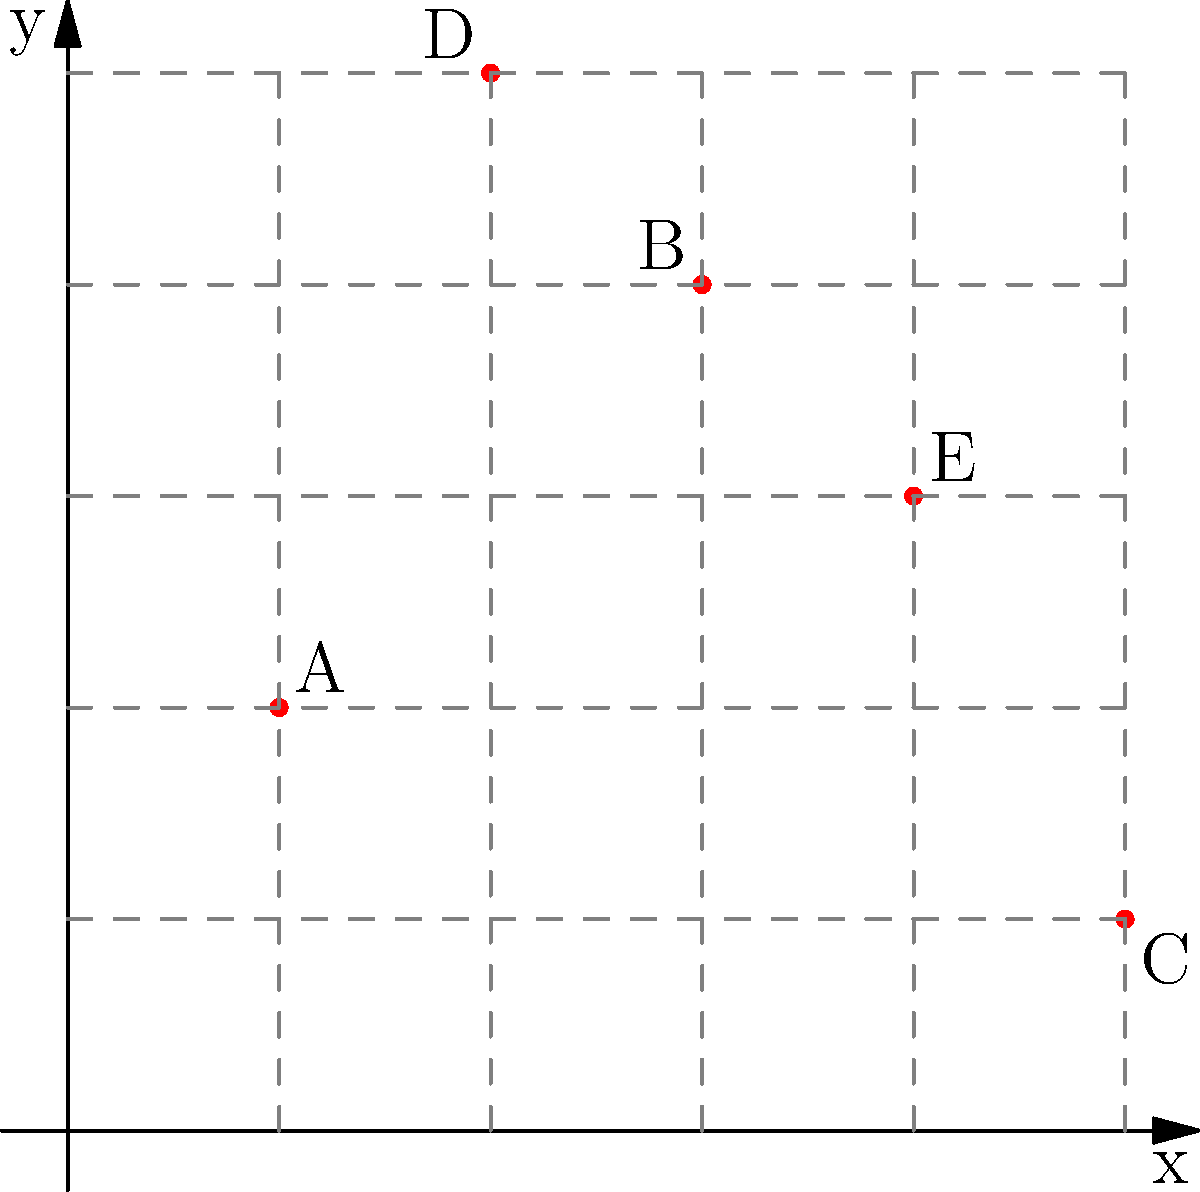As a city council member, you're presented with a map showing crime hotspots in your city. The map uses a coordinate system where each unit represents one city block. Five major hotspots (A, B, C, D, and E) have been identified. What is the Manhattan distance between the two hotspots that are farthest apart? (The Manhattan distance is the sum of the absolute differences of the coordinates.) To solve this problem, we need to:

1. Identify the coordinates of each hotspot:
   A: $(1,2)$
   B: $(3,4)$
   C: $(5,1)$
   D: $(2,5)$
   E: $(4,3)$

2. Calculate the Manhattan distance between each pair of points using the formula:
   $d = |x_2 - x_1| + |y_2 - y_1|$

3. Find the largest distance among all pairs.

Let's calculate the distances:

AC: $|5-1| + |1-2| = 4 + 1 = 5$
AD: $|2-1| + |5-2| = 1 + 3 = 4$
AE: $|4-1| + |3-2| = 3 + 1 = 4$
BC: $|5-3| + |1-4| = 2 + 3 = 5$
BD: $|2-3| + |5-4| = 1 + 1 = 2$
BE: $|4-3| + |3-4| = 1 + 1 = 2$
CD: $|2-5| + |5-1| = 3 + 4 = 7$
CE: $|4-5| + |3-1| = 1 + 2 = 3$
DE: $|4-2| + |3-5| = 2 + 2 = 4$

The largest Manhattan distance is between points C and D, which is 7 blocks.
Answer: 7 blocks 